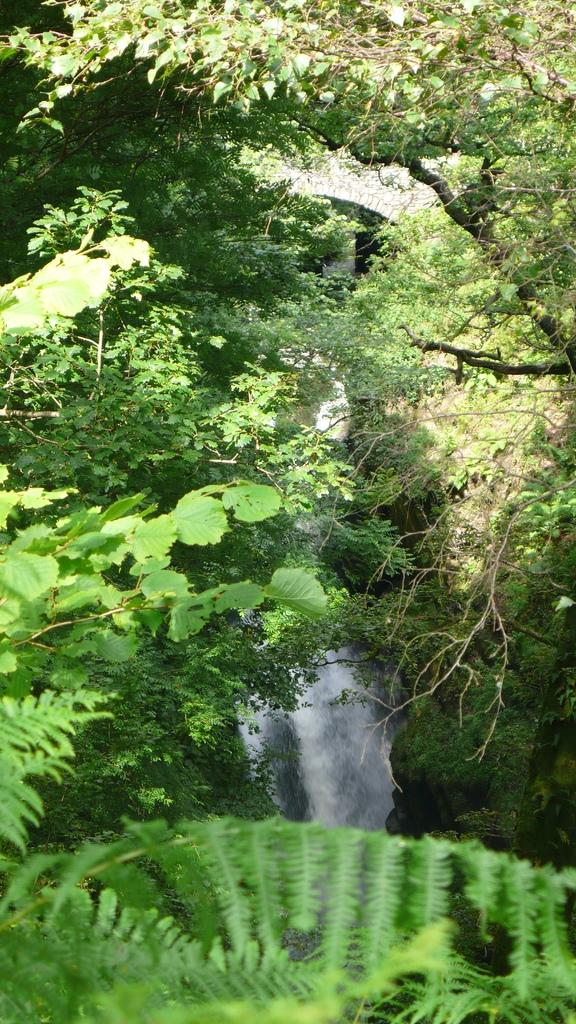What type of vegetation can be seen in the image? There are trees in the image. What natural element is also present in the image? There is water in the image. What type of ground cover is visible in the image? There is grass in the image. What man-made structure can be seen in the image? There is a wall in the image. When was the image taken? The image was taken during the day. What type of popcorn is being developed in the middle of the image? There is no popcorn or development process present in the image. 